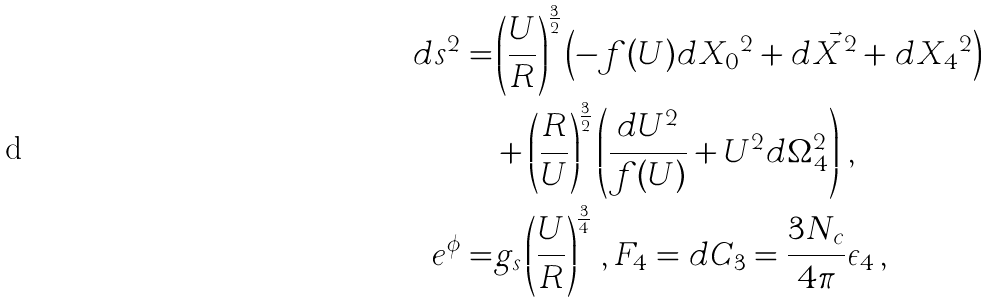Convert formula to latex. <formula><loc_0><loc_0><loc_500><loc_500>d s ^ { 2 } = & \left ( \frac { U } { R } \right ) ^ { \frac { 3 } { 2 } } \left ( - f ( U ) d { X _ { 0 } } ^ { 2 } + d \vec { X } ^ { 2 } + d { X _ { 4 } } ^ { 2 } \right ) \\ & + \left ( \frac { R } { U } \right ) ^ { \frac { 3 } { 2 } } \left ( \frac { d U ^ { 2 } } { f ( U ) } + U ^ { 2 } d \Omega _ { 4 } ^ { 2 } \right ) \, , \\ e ^ { \phi } = & g _ { s } \left ( \frac { U } { R } \right ) ^ { \frac { 3 } { 4 } } \, , F _ { 4 } = d C _ { 3 } = \frac { 3 N _ { c } } { 4 \pi } \epsilon _ { 4 } \, ,</formula> 